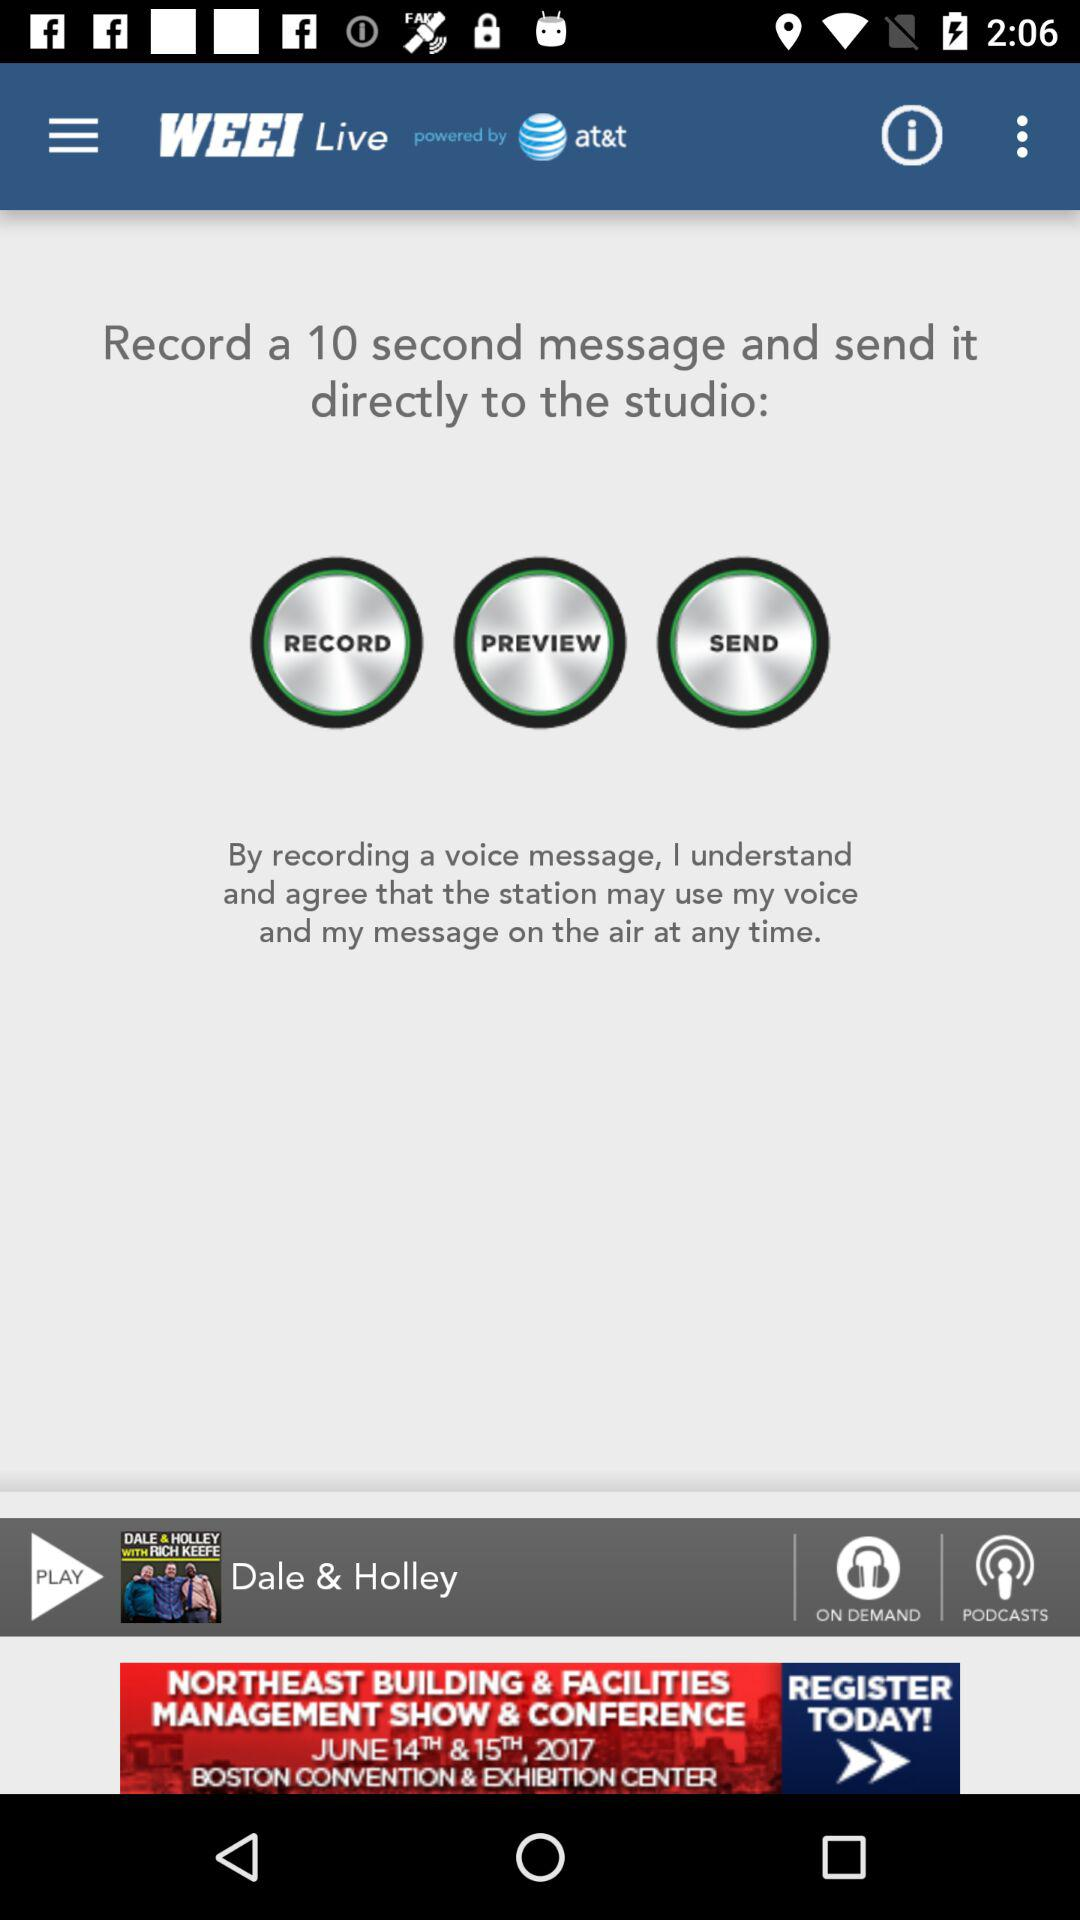What is the duration of the message that you can record? The duration of the message that you can record is 10 seconds. 